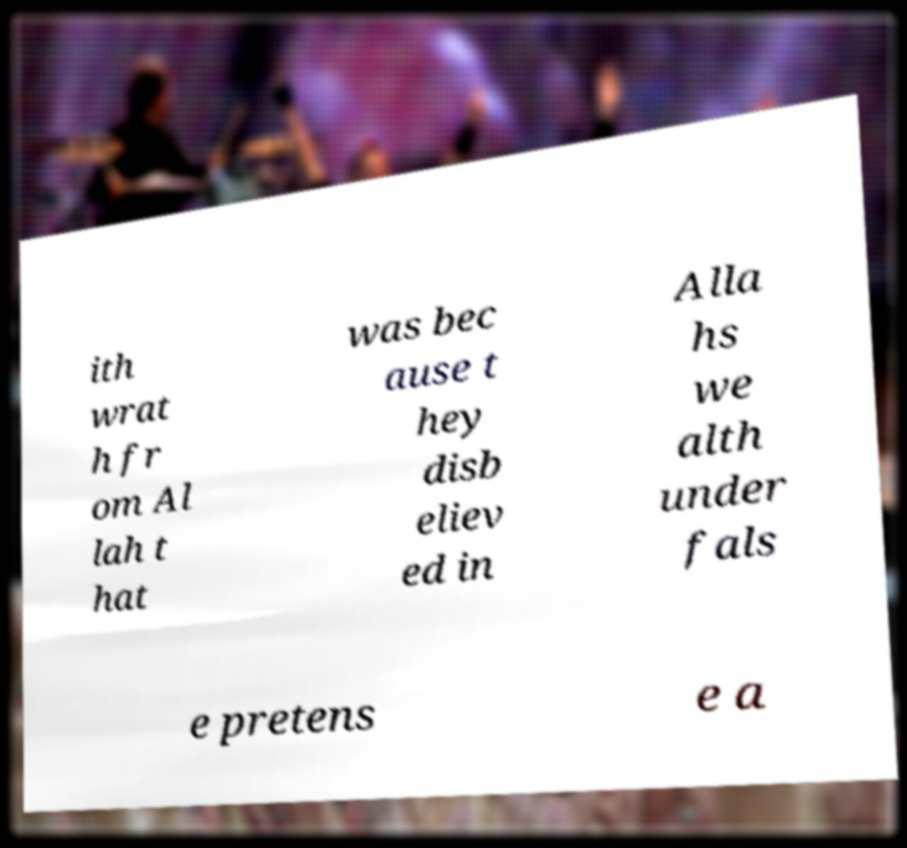For documentation purposes, I need the text within this image transcribed. Could you provide that? ith wrat h fr om Al lah t hat was bec ause t hey disb eliev ed in Alla hs we alth under fals e pretens e a 